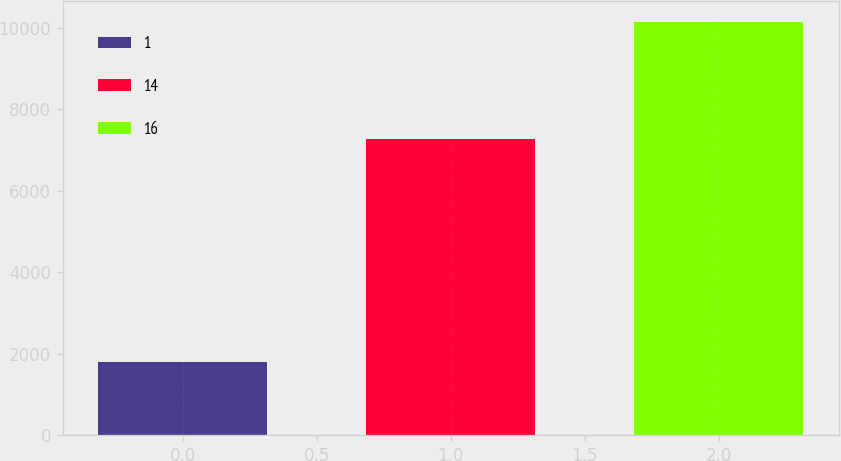Convert chart. <chart><loc_0><loc_0><loc_500><loc_500><bar_chart><fcel>1<fcel>14<fcel>16<nl><fcel>1790<fcel>7262<fcel>10144<nl></chart> 